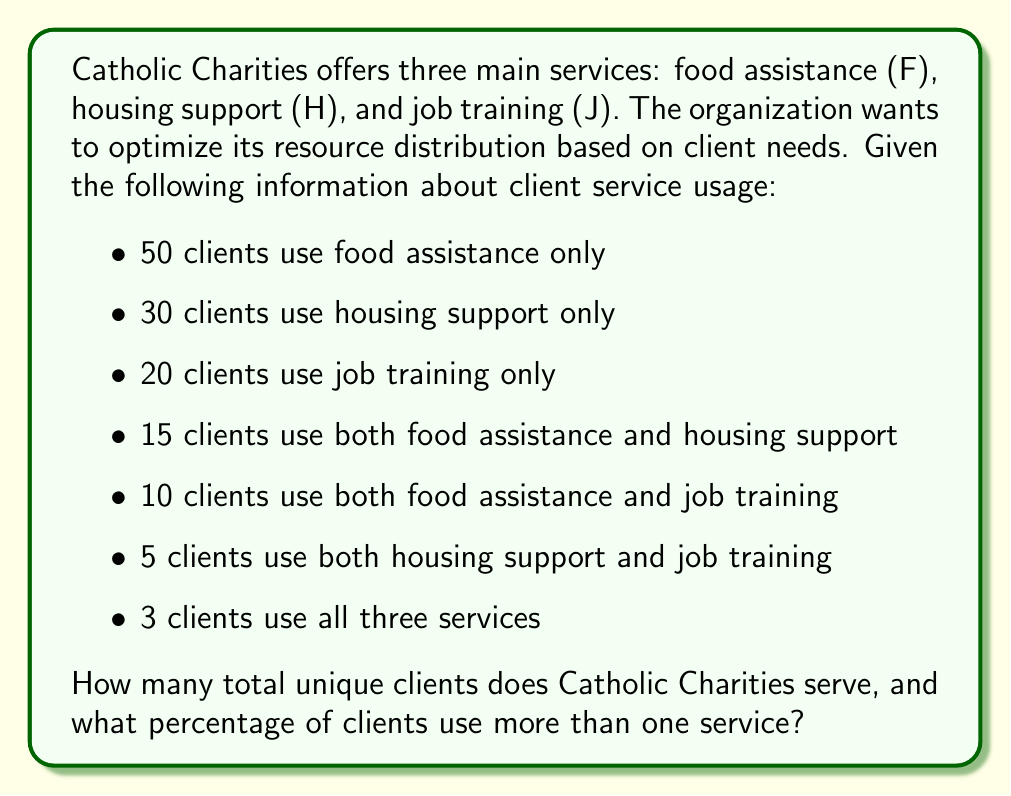Show me your answer to this math problem. To solve this problem, we'll use set theory concepts, specifically the principle of inclusion-exclusion for three sets.

Let's define our sets:
$F$: clients using food assistance
$H$: clients using housing support
$J$: clients using job training

Step 1: Calculate the total number of unique clients.

Using the inclusion-exclusion principle:
$$|F \cup H \cup J| = |F| + |H| + |J| - |F \cap H| - |F \cap J| - |H \cap J| + |F \cap H \cap J|$$

We know:
$|F| = 50 + 15 + 10 + 3 = 78$
$|H| = 30 + 15 + 5 + 3 = 53$
$|J| = 20 + 10 + 5 + 3 = 38$
$|F \cap H| = 15 + 3 = 18$
$|F \cap J| = 10 + 3 = 13$
$|H \cap J| = 5 + 3 = 8$
$|F \cap H \cap J| = 3$

Substituting these values:
$$|F \cup H \cup J| = 78 + 53 + 38 - 18 - 13 - 8 + 3 = 133$$

Step 2: Calculate the number of clients using more than one service.

Clients using more than one service = $(|F \cap H| - |F \cap H \cap J|) + (|F \cap J| - |F \cap H \cap J|) + (|H \cap J| - |F \cap H \cap J|) + |F \cap H \cap J|$
$= (18 - 3) + (13 - 3) + (8 - 3) + 3 = 15 + 10 + 5 + 3 = 33$

Step 3: Calculate the percentage of clients using more than one service.

Percentage = $\frac{\text{Clients using more than one service}}{\text{Total unique clients}} \times 100\%$
$= \frac{33}{133} \times 100\% \approx 24.81\%$
Answer: Catholic Charities serves 133 total unique clients, and 24.81% of clients use more than one service. 